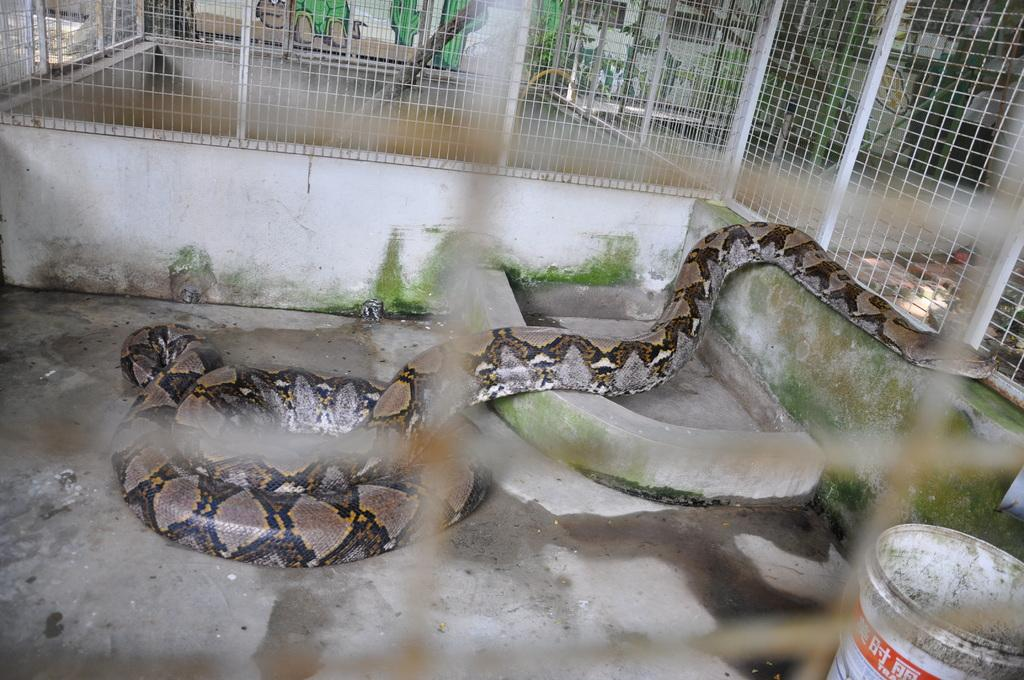What animal is present in the image? There is a snake in the image. What is the snake resting on? The snake is on a surface. How is the snake contained or separated from its surroundings? There is a fence around the snake. What object is located near the snake? There is a bucket to the side of the snake. What can be seen in the background of the image? There is a wall with pictures on it in the background of the image. What month is it in the image? The month is not mentioned or depicted in the image, so it cannot be determined. Can you see a frame around the pictures on the wall in the background? The presence of a frame around the pictures on the wall is not mentioned in the provided facts, so it cannot be determined. 